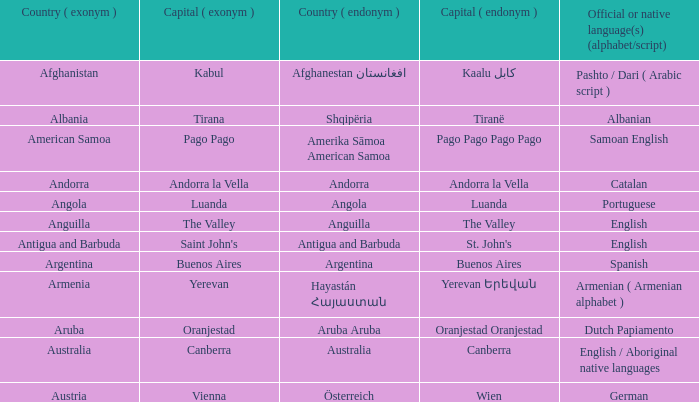In which country is dutch papiamento the official native language, and what is its english name? Aruba. 